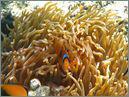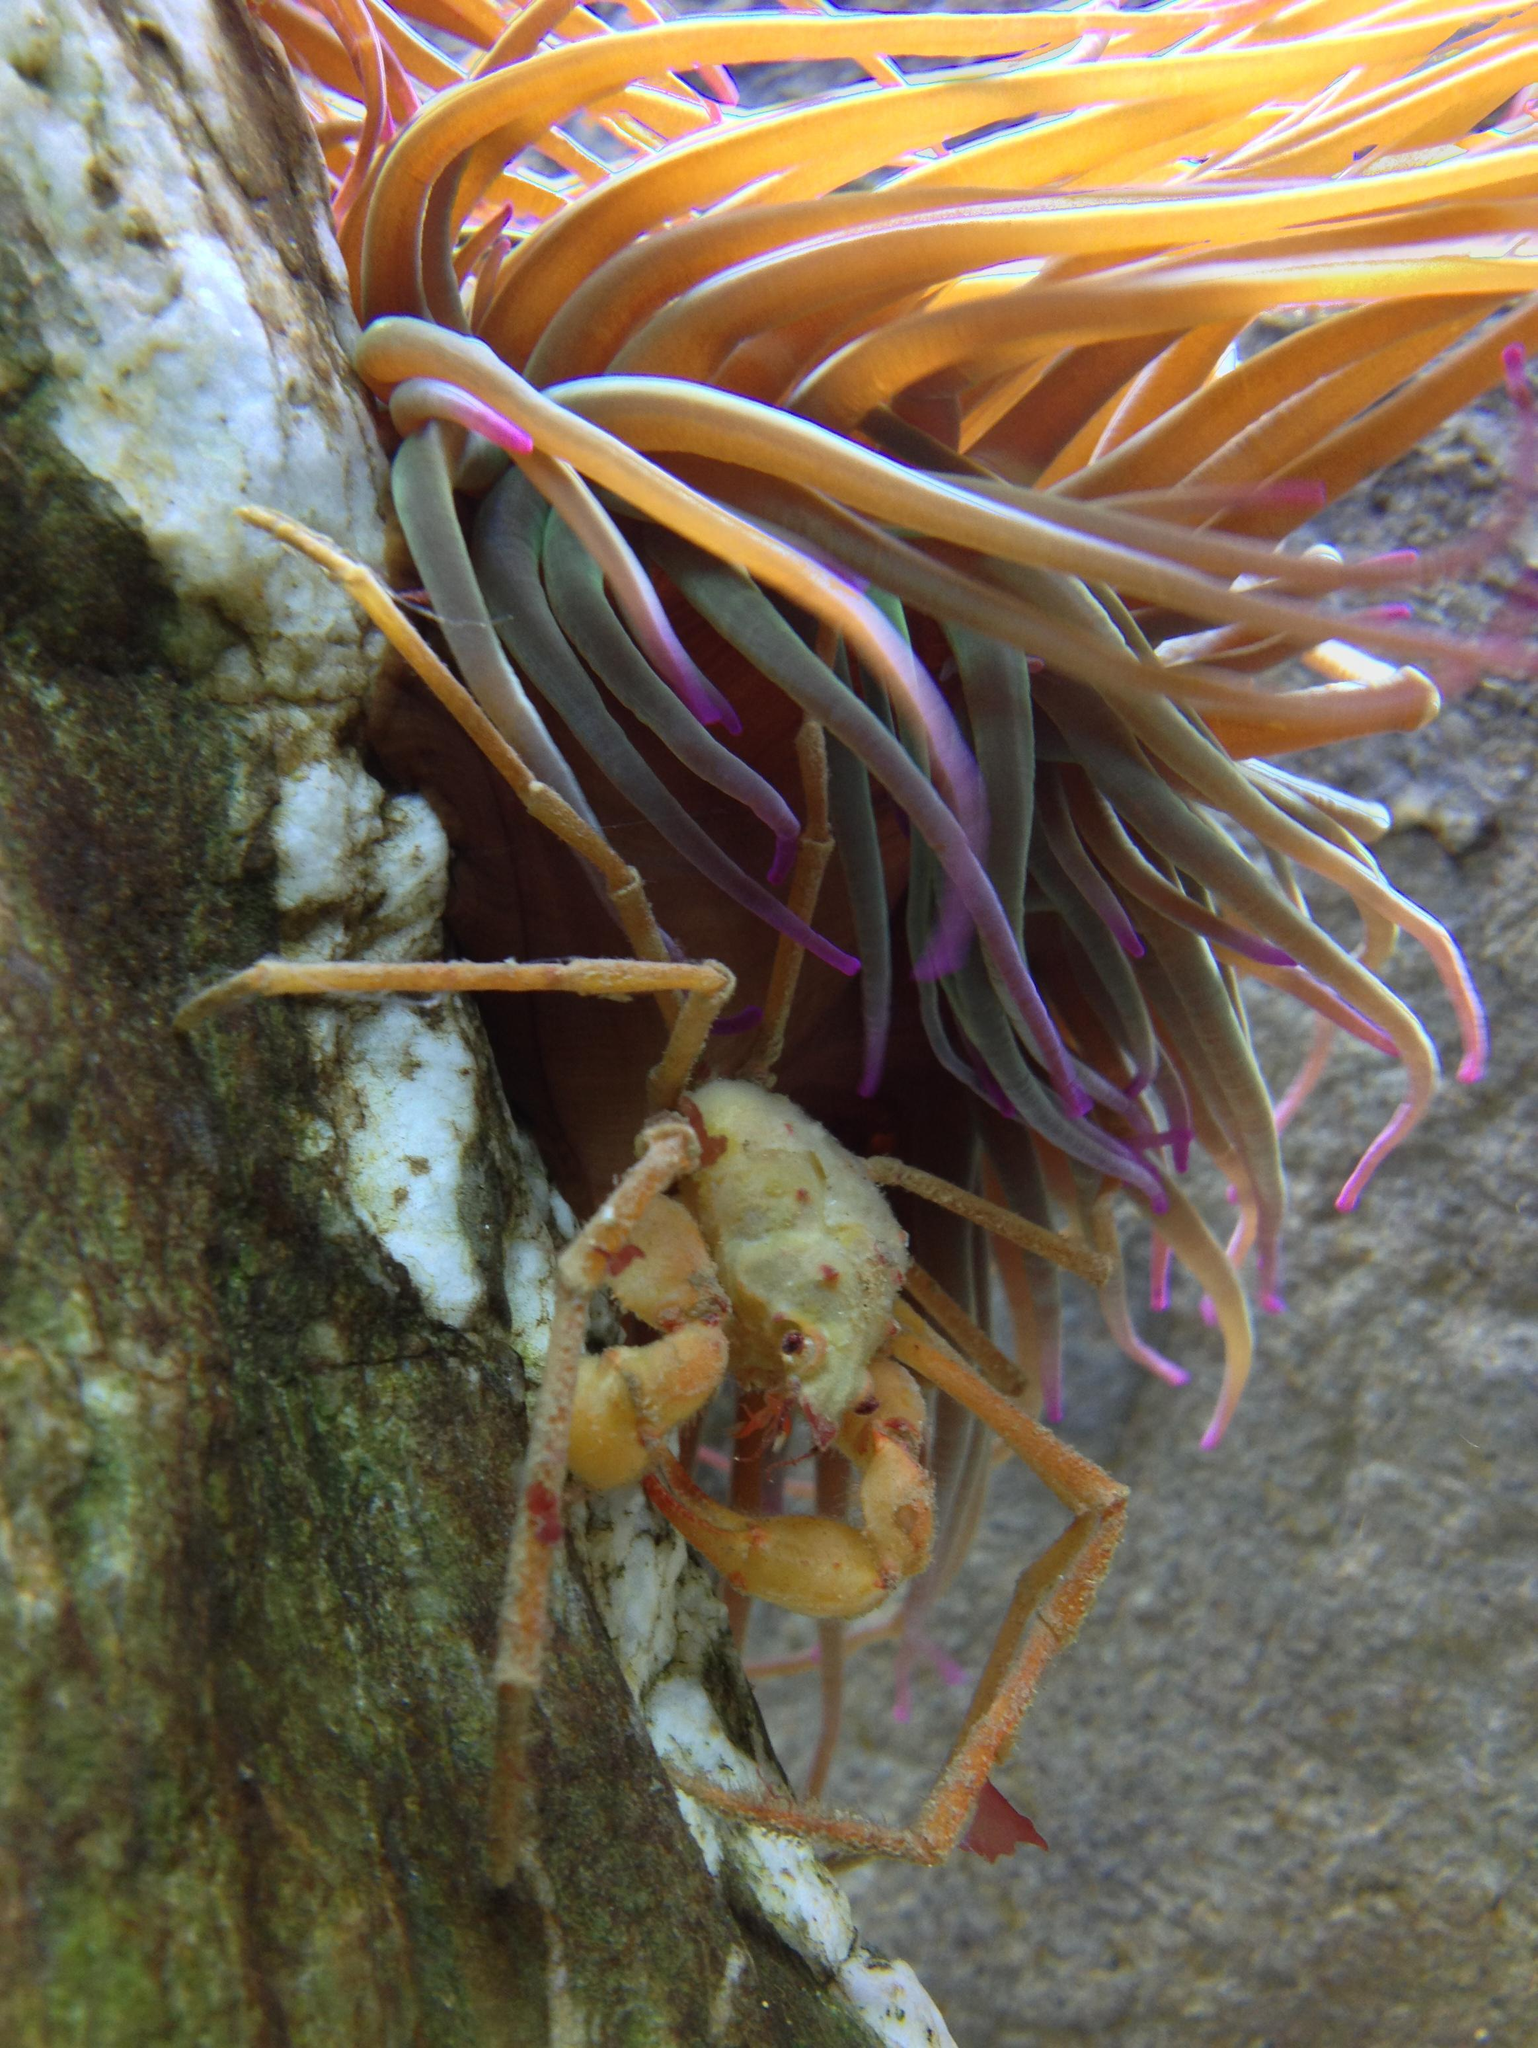The first image is the image on the left, the second image is the image on the right. For the images displayed, is the sentence "There are no fish in the left image." factually correct? Answer yes or no. No. The first image is the image on the left, the second image is the image on the right. Evaluate the accuracy of this statement regarding the images: "The left image shows clown fish swimming in the noodle-like yellowish tendrils of anemone.". Is it true? Answer yes or no. Yes. 